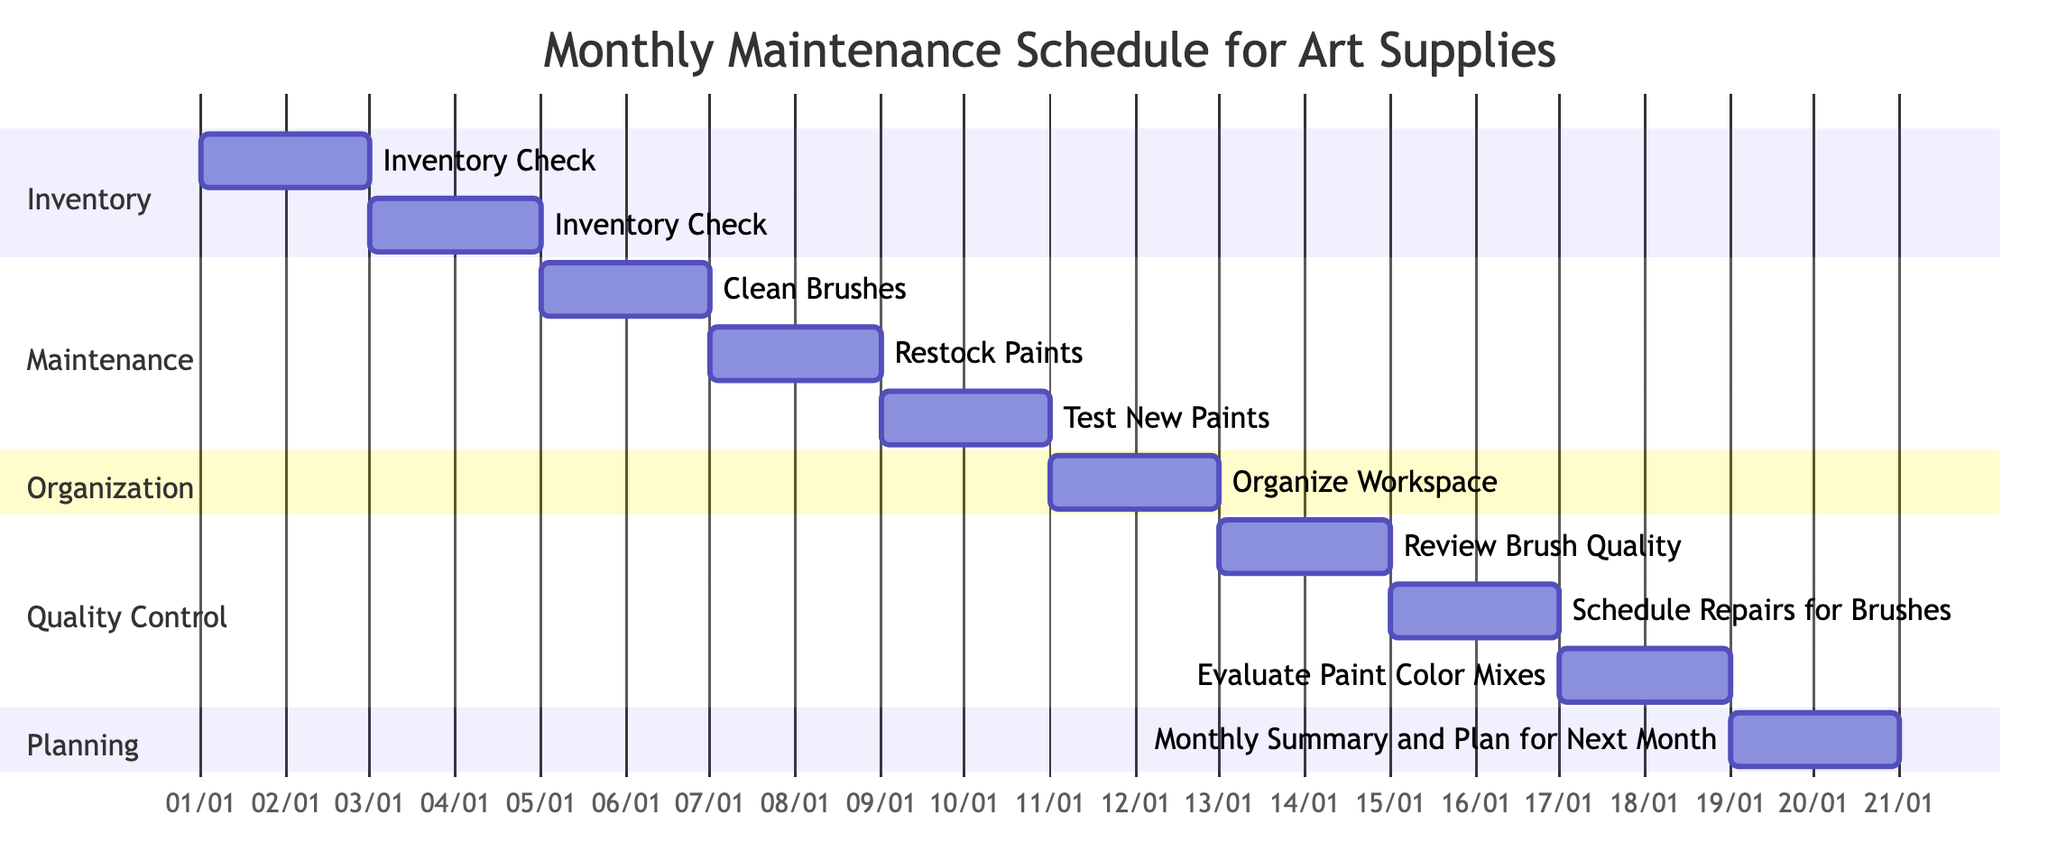What is the total number of tasks listed in the diagram? The diagram includes a section for Inventory, Maintenance, Organization, Quality Control, and Planning, each containing a number of tasks. By counting each task from all sections, there are ten tasks total in the diagram.
Answer: 10 Which task is scheduled for January 11th? By examining the timeline of the Gantt chart, the task scheduled for January 11th falls under the Organization section, specifically "Organize Workspace."
Answer: Organize Workspace What tasks are categorized under the Quality Control section? The Quality Control section of the diagram lists three tasks: "Review Brush Quality," "Schedule Repairs for Brushes," and "Evaluate Paint Color Mixes." These tasks can be identified by looking under the associated section on the chart.
Answer: Review Brush Quality, Schedule Repairs for Brushes, Evaluate Paint Color Mixes When does the "Test New Paints" task begin? The Gantt chart indicates that the "Test New Paints" task begins on January 9th. This is confirmed by locating the task and reading the start date on the timeline.
Answer: January 9th How many tasks are scheduled to occur in January? All tasks listed in the Gantt chart are scheduled within the month of January, and by counting them, we determine there are a total of ten tasks.
Answer: 10 Which task follows "Restock Paints"? In the timeline of the Gantt chart, "Restock Paints" is followed by the task "Test New Paints," which begins on January 9th, right after "Restock Paints," which ends on January 8th.
Answer: Test New Paints What is the duration of the task "Clean Brushes"? The "Clean Brushes" task is scheduled to start on January 5th and end on January 6th, lasting for a total of two days as indicated on the chart.
Answer: 2 days What section does "Monthly Summary and Plan for Next Month" belong to? This task is categorized under the Planning section in the Gantt chart, as denoted by its labeling within the various sections.
Answer: Planning What is the ending date for "Evaluate Paint Color Mixes"? The Gantt chart shows that "Evaluate Paint Color Mixes" ends on January 18th. This conclusion is reached by checking the end date listed next to the task in the Quality Control section.
Answer: January 18th 